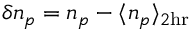<formula> <loc_0><loc_0><loc_500><loc_500>\delta n _ { p } = n _ { p } - \langle n _ { p } \rangle _ { 2 h r }</formula> 